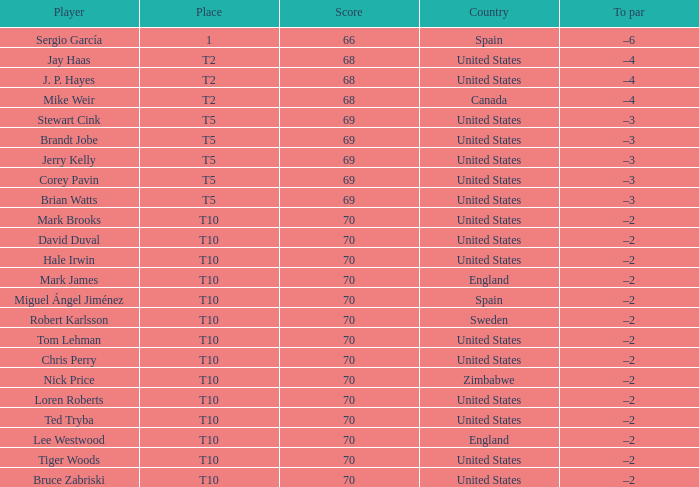Could you parse the entire table as a dict? {'header': ['Player', 'Place', 'Score', 'Country', 'To par'], 'rows': [['Sergio García', '1', '66', 'Spain', '–6'], ['Jay Haas', 'T2', '68', 'United States', '–4'], ['J. P. Hayes', 'T2', '68', 'United States', '–4'], ['Mike Weir', 'T2', '68', 'Canada', '–4'], ['Stewart Cink', 'T5', '69', 'United States', '–3'], ['Brandt Jobe', 'T5', '69', 'United States', '–3'], ['Jerry Kelly', 'T5', '69', 'United States', '–3'], ['Corey Pavin', 'T5', '69', 'United States', '–3'], ['Brian Watts', 'T5', '69', 'United States', '–3'], ['Mark Brooks', 'T10', '70', 'United States', '–2'], ['David Duval', 'T10', '70', 'United States', '–2'], ['Hale Irwin', 'T10', '70', 'United States', '–2'], ['Mark James', 'T10', '70', 'England', '–2'], ['Miguel Ángel Jiménez', 'T10', '70', 'Spain', '–2'], ['Robert Karlsson', 'T10', '70', 'Sweden', '–2'], ['Tom Lehman', 'T10', '70', 'United States', '–2'], ['Chris Perry', 'T10', '70', 'United States', '–2'], ['Nick Price', 'T10', '70', 'Zimbabwe', '–2'], ['Loren Roberts', 'T10', '70', 'United States', '–2'], ['Ted Tryba', 'T10', '70', 'United States', '–2'], ['Lee Westwood', 'T10', '70', 'England', '–2'], ['Tiger Woods', 'T10', '70', 'United States', '–2'], ['Bruce Zabriski', 'T10', '70', 'United States', '–2']]} What was the highest score of t5 place finisher brandt jobe? 69.0. 